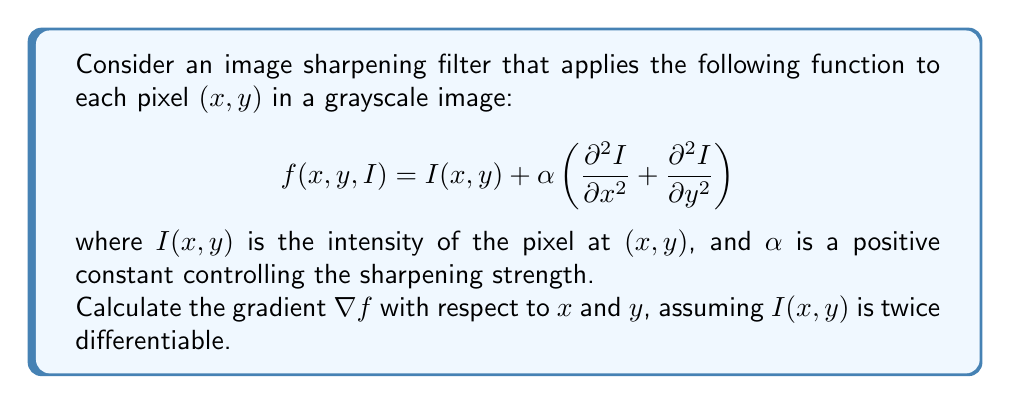What is the answer to this math problem? To calculate the gradient $\nabla f$, we need to find the partial derivatives of $f$ with respect to $x$ and $y$. Let's proceed step by step:

1) The gradient is defined as:
   $$\nabla f = \left(\frac{\partial f}{\partial x}, \frac{\partial f}{\partial y}\right)$$

2) Let's calculate $\frac{\partial f}{\partial x}$:
   $$\begin{align}
   \frac{\partial f}{\partial x} &= \frac{\partial}{\partial x}\left[I(x, y) + \alpha \left(\frac{\partial^2 I}{\partial x^2} + \frac{\partial^2 I}{\partial y^2}\right)\right] \\
   &= \frac{\partial I}{\partial x} + \alpha \left(\frac{\partial^3 I}{\partial x^3} + \frac{\partial^3 I}{\partial x\partial y^2}\right)
   \end{align}$$

3) Similarly, for $\frac{\partial f}{\partial y}$:
   $$\begin{align}
   \frac{\partial f}{\partial y} &= \frac{\partial}{\partial y}\left[I(x, y) + \alpha \left(\frac{\partial^2 I}{\partial x^2} + \frac{\partial^2 I}{\partial y^2}\right)\right] \\
   &= \frac{\partial I}{\partial y} + \alpha \left(\frac{\partial^3 I}{\partial x^2\partial y} + \frac{\partial^3 I}{\partial y^3}\right)
   \end{align}$$

4) Therefore, the gradient $\nabla f$ is:
   $$\nabla f = \left(\frac{\partial I}{\partial x} + \alpha \left(\frac{\partial^3 I}{\partial x^3} + \frac{\partial^3 I}{\partial x\partial y^2}\right), \frac{\partial I}{\partial y} + \alpha \left(\frac{\partial^3 I}{\partial x^2\partial y} + \frac{\partial^3 I}{\partial y^3}\right)\right)$$

This gradient represents how the sharpened image intensity changes with respect to small changes in $x$ and $y$ coordinates.
Answer: $$\nabla f = \left(\frac{\partial I}{\partial x} + \alpha \left(\frac{\partial^3 I}{\partial x^3} + \frac{\partial^3 I}{\partial x\partial y^2}\right), \frac{\partial I}{\partial y} + \alpha \left(\frac{\partial^3 I}{\partial x^2\partial y} + \frac{\partial^3 I}{\partial y^3}\right)\right)$$ 